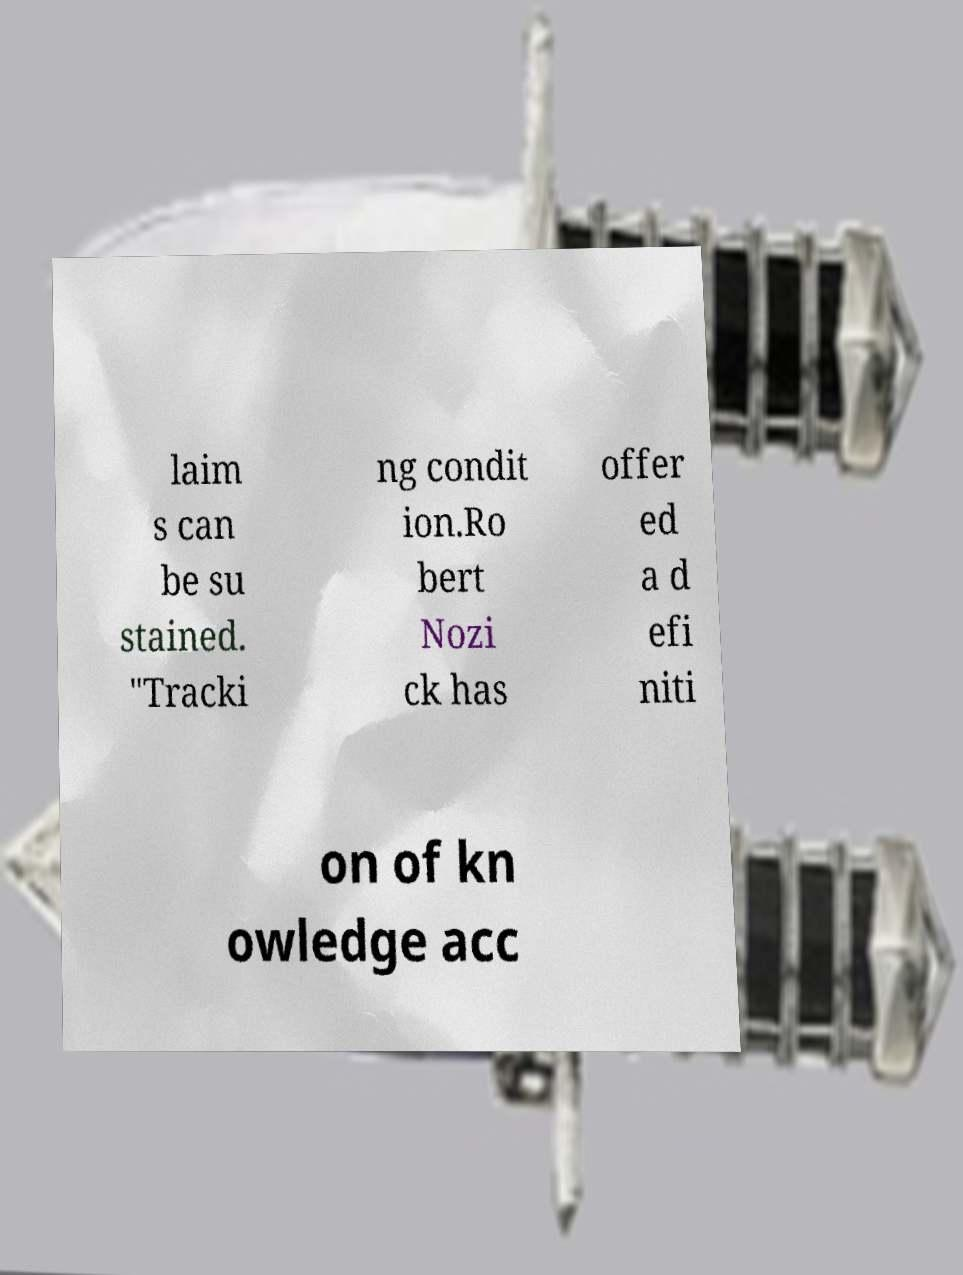Can you read and provide the text displayed in the image?This photo seems to have some interesting text. Can you extract and type it out for me? laim s can be su stained. "Tracki ng condit ion.Ro bert Nozi ck has offer ed a d efi niti on of kn owledge acc 